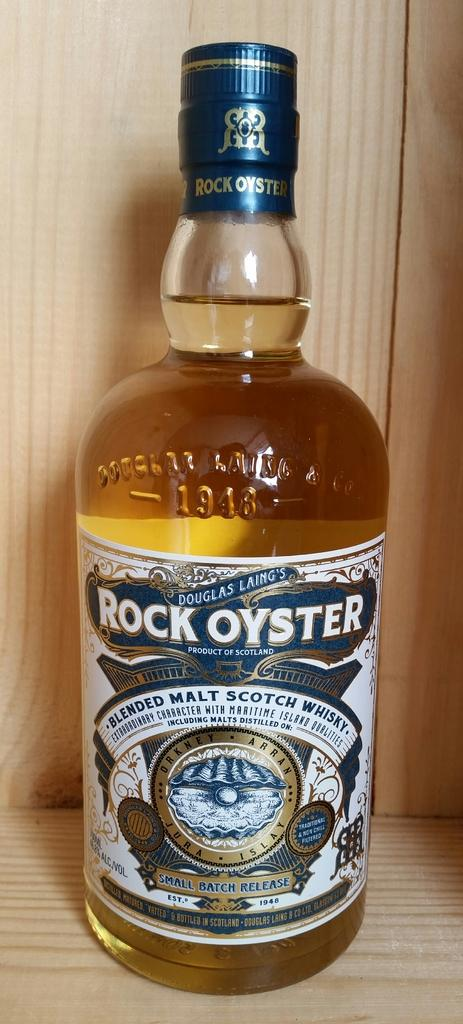What object can be seen in the image? There is a bottle in the image. Where is the bottle located? The bottle is on a table. What type of tin is present in the image? There is no tin present in the image; it only features a bottle on a table. 